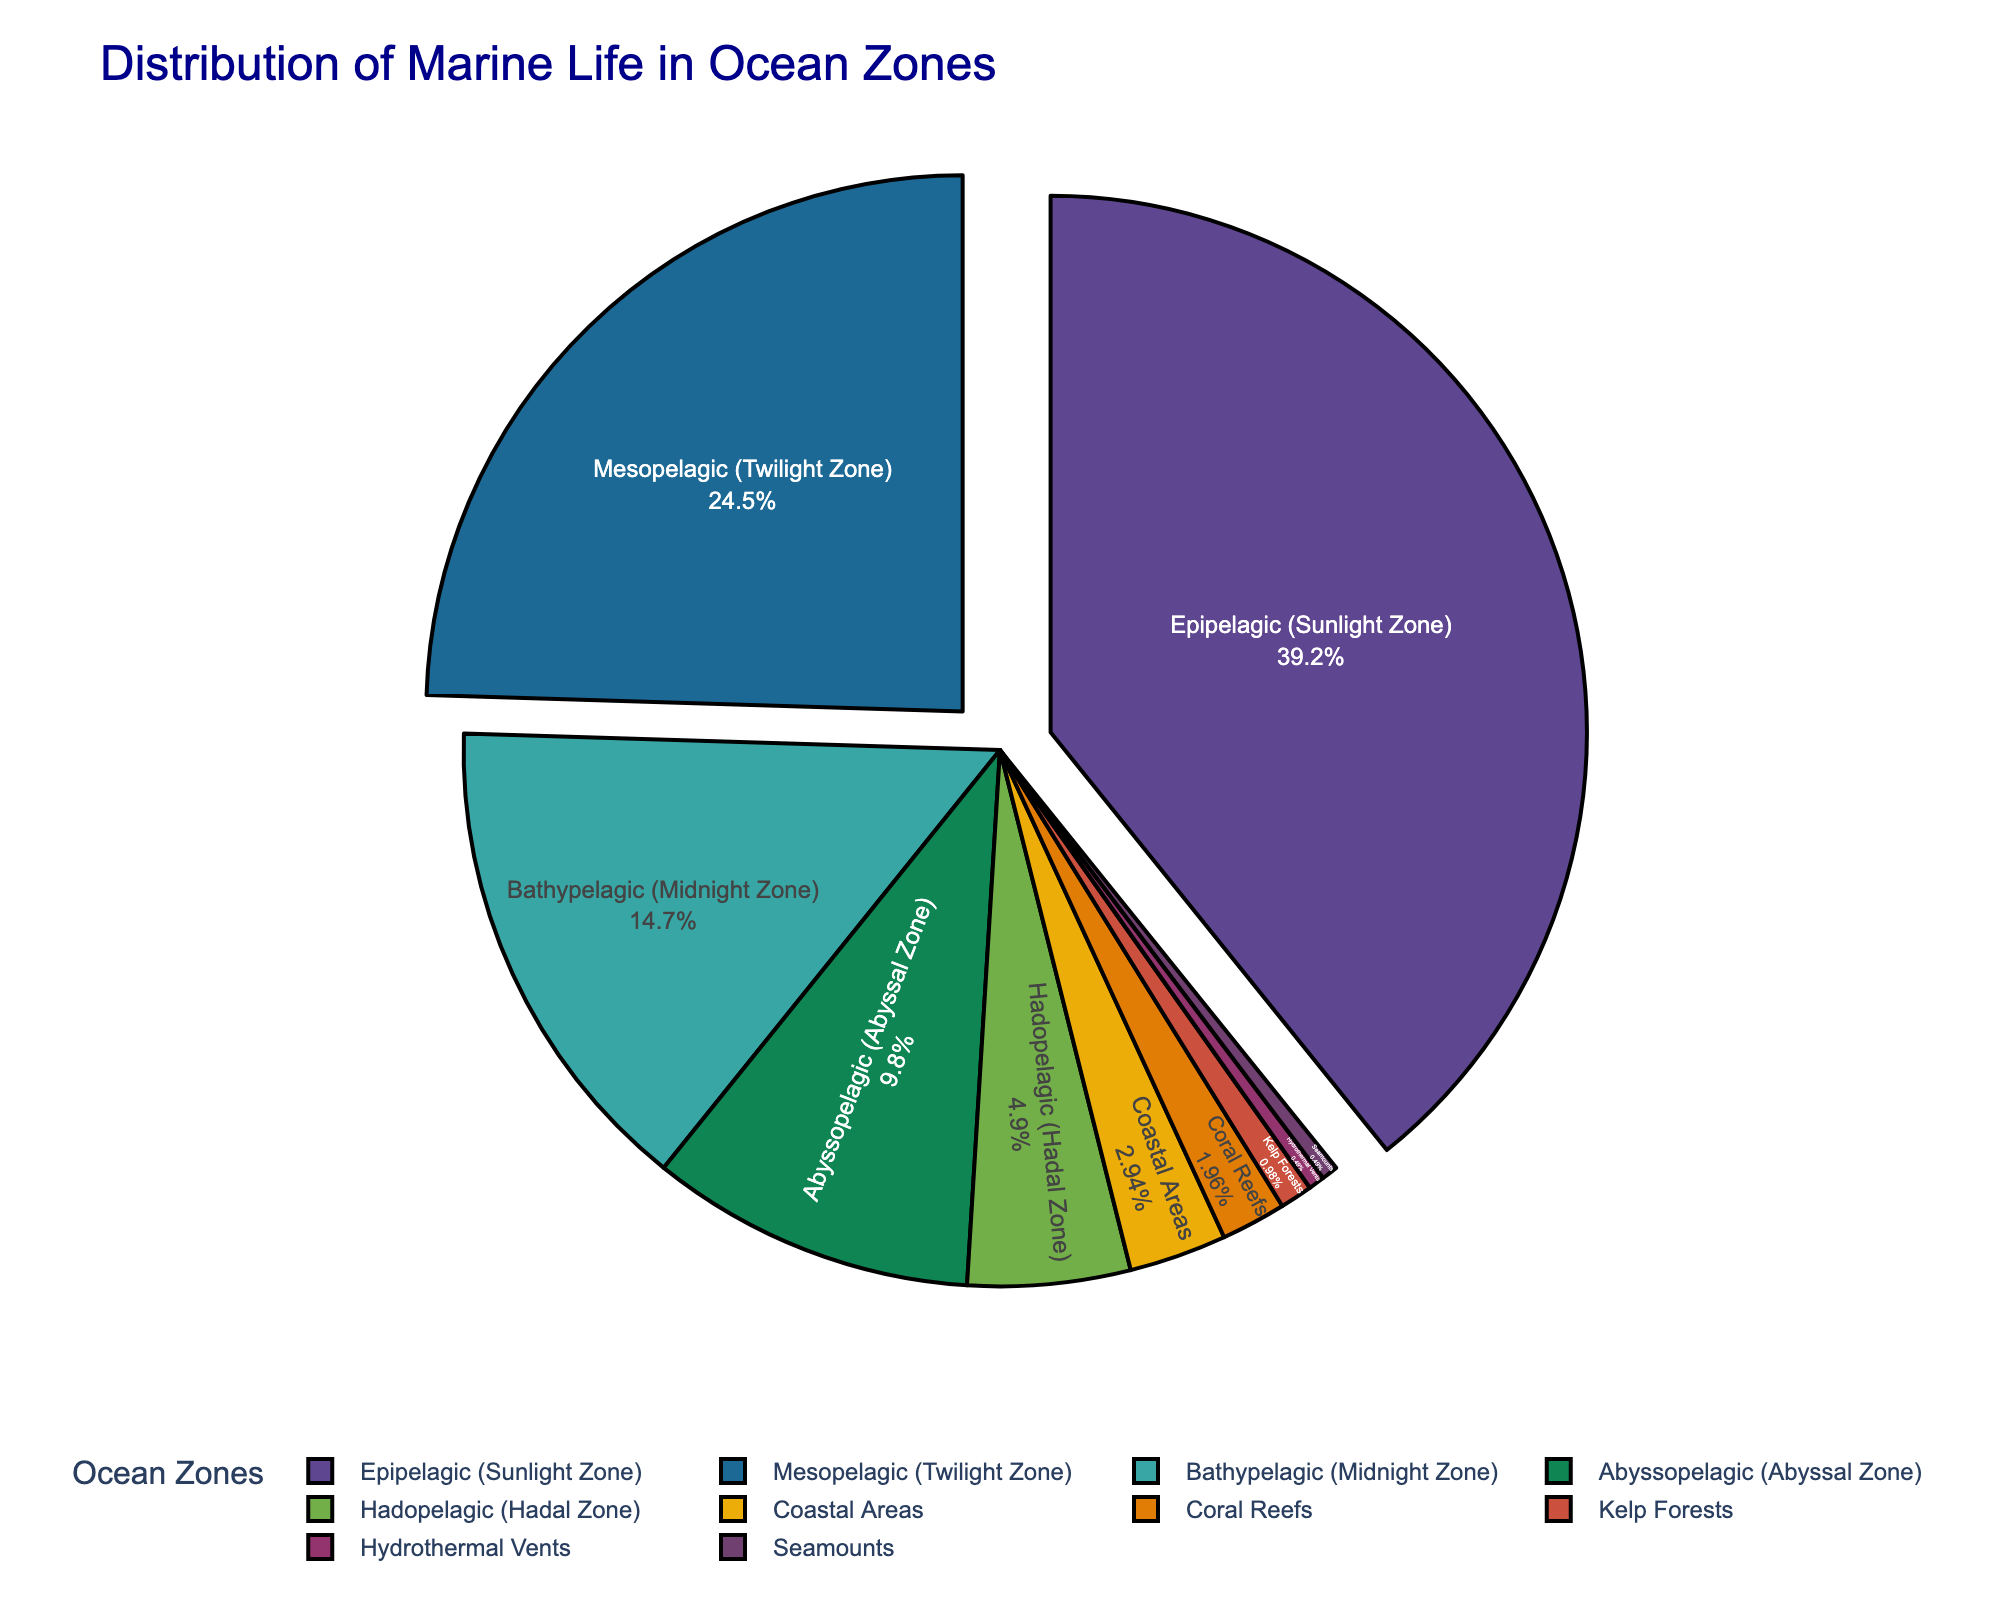Which ocean zone contains the highest percentage of marine life? The question asks for the ocean zone with the largest portion in the pie chart. By looking at the chart, the Epipelagic (Sunlight Zone) segment is the largest.
Answer: Epipelagic (Sunlight Zone) Which ocean zones together account for 50% of marine life? By summing the percentages, Epipelagic (40%) and Mesopelagic (25%) together exceed 50%. However, to exactly achieve 50%, we need to include the Bathypelagic zone as well. Adding Epipelagic (40%) and Bathypelagic (15%) equals 55%, which is slightly over 50%, so the exact split does not exist by just combining two zones.
Answer: Epipelagic (Sunlight Zone) and any zone lower in percentage Does the percentage of marine life in the Mesopelagic (Twilight Zone) exceed that of the Abyssopelagic (Abyssal Zone) and Hadopelagic (Hadal Zone) combined? The Mesopelagic zone accounts for 25%. The Abyssopelagic and Hadopelagic zones combined account for 10% + 5% = 15%. Thus, 25% > 15% is true.
Answer: Yes What is the sum of percentages for marine life in Coral Reefs and Kelp Forests? Coral Reefs contribute 2%, and Kelp Forests contribute 1%. Adding them together gives 2% + 1% = 3%.
Answer: 3% Compare the marine life distribution in Abyssopelagic and Coastal Areas. Which has more marine life? Abyssopelagic has 10%, and Coastal Areas have 3%. Since 10% > 3%, Abyssopelagic has more.
Answer: Abyssopelagic (Abyssal Zone) Which ocean zone is represented by the smallest portion of marine life? The smallest segment in the pie chart is for Hydrothermal Vents and Seamounts, each contributing 0.5%.
Answer: Hydrothermal Vents / Seamounts How much more marine life is found in the Mesopelagic (Twilight Zone) compared to the Coastal Areas? The Mesopelagic zone has 25%, and Coastal Areas have 3%. The difference is 25% - 3% = 22%.
Answer: 22% What are the combined percentages for non-deep ocean zones (defined as Coastal Areas, Coral Reefs, Kelp Forests)? Coastal Areas (3%) + Coral Reefs (2%) + Kelp Forests (1%) = 3% + 2% + 1% = 6%.
Answer: 6% 